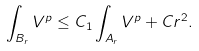Convert formula to latex. <formula><loc_0><loc_0><loc_500><loc_500>\int _ { B _ { r } } V ^ { p } \leq C _ { 1 } \int _ { A _ { r } } V ^ { p } + C r ^ { 2 } .</formula> 